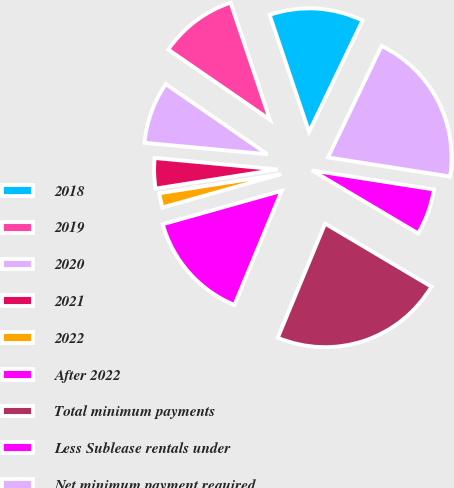<chart> <loc_0><loc_0><loc_500><loc_500><pie_chart><fcel>2018<fcel>2019<fcel>2020<fcel>2021<fcel>2022<fcel>After 2022<fcel>Total minimum payments<fcel>Less Sublease rentals under<fcel>Net minimum payment required<nl><fcel>12.3%<fcel>10.22%<fcel>8.13%<fcel>3.96%<fcel>1.88%<fcel>14.39%<fcel>22.73%<fcel>6.05%<fcel>20.35%<nl></chart> 